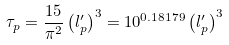<formula> <loc_0><loc_0><loc_500><loc_500>\tau _ { p } = \frac { 1 5 } { \pi ^ { 2 } } \left ( l _ { p } ^ { \prime } \right ) ^ { 3 } = 1 0 ^ { 0 . 1 8 1 7 9 } \left ( l _ { p } ^ { \prime } \right ) ^ { 3 }</formula> 